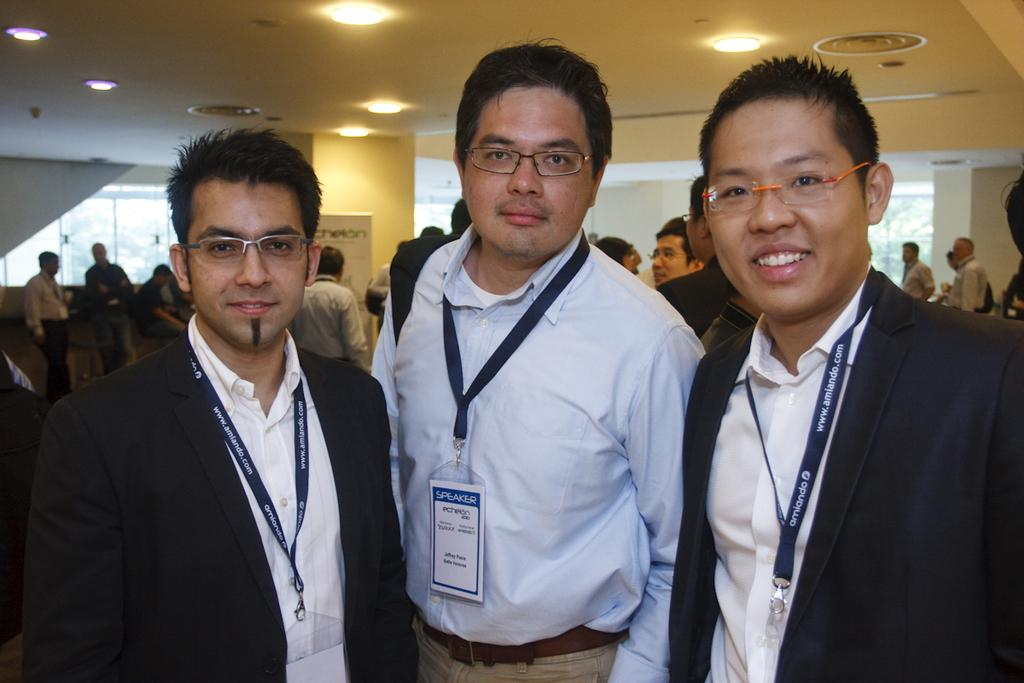How many people are in the group that is visible in the image? There is a group of people in the image, but the exact number is not specified. What can be seen on some of the people in the group? Some people in the group are wearing identity cards. What is the purpose of the banner in the image? The purpose of the banner is not specified in the facts provided. What type of structure is visible in the image? There is a wall in the image. What can be seen illuminating the area in the image? There are lights in the image. What architectural feature is visible in the image? There are windows in the image. What type of tax can be seen being collected in the image? There is no mention of tax or any tax-related activity in the image. What kind of string is being used to hold up the clouds in the image? There are no clouds or any string visible in the image. 